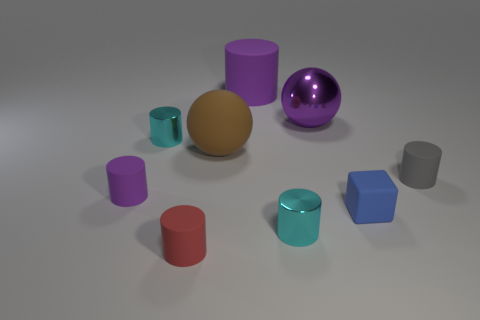How many objects are large brown things or red rubber objects?
Provide a short and direct response. 2. Do the tiny cube and the thing that is to the right of the cube have the same material?
Provide a short and direct response. Yes. There is a purple matte cylinder that is to the right of the red object; what is its size?
Keep it short and to the point. Large. Are there fewer big cylinders than tiny metal cylinders?
Offer a terse response. Yes. Are there any big things that have the same color as the matte sphere?
Provide a short and direct response. No. What is the shape of the matte thing that is behind the rubber block and on the right side of the large metallic object?
Ensure brevity in your answer.  Cylinder. What shape is the big brown object right of the small cyan object behind the brown object?
Offer a very short reply. Sphere. Does the large purple metal thing have the same shape as the tiny gray rubber thing?
Provide a succinct answer. No. There is a tiny cylinder that is the same color as the big cylinder; what is its material?
Offer a very short reply. Rubber. Does the large metal sphere have the same color as the large cylinder?
Provide a short and direct response. Yes. 